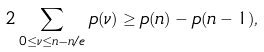Convert formula to latex. <formula><loc_0><loc_0><loc_500><loc_500>2 \sum _ { 0 \leq \nu \leq n - n / e } p ( \nu ) \geq p ( n ) - p ( n - 1 ) ,</formula> 